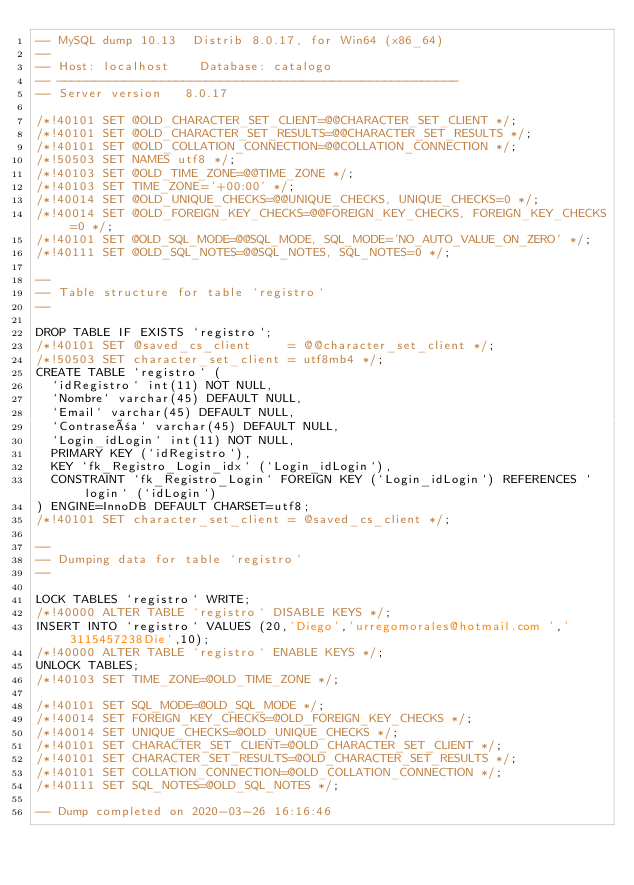<code> <loc_0><loc_0><loc_500><loc_500><_SQL_>-- MySQL dump 10.13  Distrib 8.0.17, for Win64 (x86_64)
--
-- Host: localhost    Database: catalogo
-- ------------------------------------------------------
-- Server version	8.0.17

/*!40101 SET @OLD_CHARACTER_SET_CLIENT=@@CHARACTER_SET_CLIENT */;
/*!40101 SET @OLD_CHARACTER_SET_RESULTS=@@CHARACTER_SET_RESULTS */;
/*!40101 SET @OLD_COLLATION_CONNECTION=@@COLLATION_CONNECTION */;
/*!50503 SET NAMES utf8 */;
/*!40103 SET @OLD_TIME_ZONE=@@TIME_ZONE */;
/*!40103 SET TIME_ZONE='+00:00' */;
/*!40014 SET @OLD_UNIQUE_CHECKS=@@UNIQUE_CHECKS, UNIQUE_CHECKS=0 */;
/*!40014 SET @OLD_FOREIGN_KEY_CHECKS=@@FOREIGN_KEY_CHECKS, FOREIGN_KEY_CHECKS=0 */;
/*!40101 SET @OLD_SQL_MODE=@@SQL_MODE, SQL_MODE='NO_AUTO_VALUE_ON_ZERO' */;
/*!40111 SET @OLD_SQL_NOTES=@@SQL_NOTES, SQL_NOTES=0 */;

--
-- Table structure for table `registro`
--

DROP TABLE IF EXISTS `registro`;
/*!40101 SET @saved_cs_client     = @@character_set_client */;
/*!50503 SET character_set_client = utf8mb4 */;
CREATE TABLE `registro` (
  `idRegistro` int(11) NOT NULL,
  `Nombre` varchar(45) DEFAULT NULL,
  `Email` varchar(45) DEFAULT NULL,
  `Contraseña` varchar(45) DEFAULT NULL,
  `Login_idLogin` int(11) NOT NULL,
  PRIMARY KEY (`idRegistro`),
  KEY `fk_Registro_Login_idx` (`Login_idLogin`),
  CONSTRAINT `fk_Registro_Login` FOREIGN KEY (`Login_idLogin`) REFERENCES `login` (`idLogin`)
) ENGINE=InnoDB DEFAULT CHARSET=utf8;
/*!40101 SET character_set_client = @saved_cs_client */;

--
-- Dumping data for table `registro`
--

LOCK TABLES `registro` WRITE;
/*!40000 ALTER TABLE `registro` DISABLE KEYS */;
INSERT INTO `registro` VALUES (20,'Diego','urregomorales@hotmail.com ','3115457238Die',10);
/*!40000 ALTER TABLE `registro` ENABLE KEYS */;
UNLOCK TABLES;
/*!40103 SET TIME_ZONE=@OLD_TIME_ZONE */;

/*!40101 SET SQL_MODE=@OLD_SQL_MODE */;
/*!40014 SET FOREIGN_KEY_CHECKS=@OLD_FOREIGN_KEY_CHECKS */;
/*!40014 SET UNIQUE_CHECKS=@OLD_UNIQUE_CHECKS */;
/*!40101 SET CHARACTER_SET_CLIENT=@OLD_CHARACTER_SET_CLIENT */;
/*!40101 SET CHARACTER_SET_RESULTS=@OLD_CHARACTER_SET_RESULTS */;
/*!40101 SET COLLATION_CONNECTION=@OLD_COLLATION_CONNECTION */;
/*!40111 SET SQL_NOTES=@OLD_SQL_NOTES */;

-- Dump completed on 2020-03-26 16:16:46
</code> 